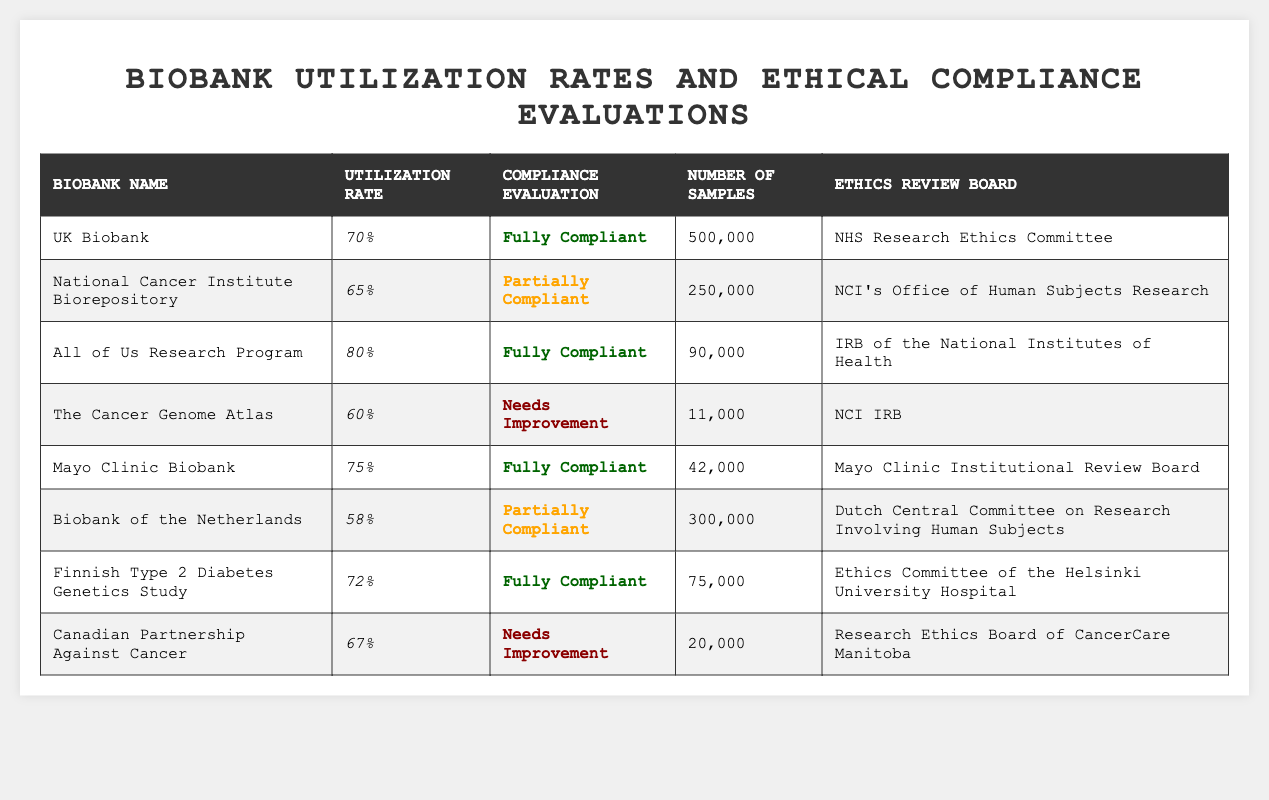What is the utilization rate of the UK Biobank? The table lists the UK Biobank's utilization rate, which is specified directly as 70%.
Answer: 70% How many samples are in the Finnish Type 2 Diabetes Genetics Study? Referring to the table, the number of samples for the Finnish Type 2 Diabetes Genetics Study is stated as 75,000.
Answer: 75,000 Which biobank has the highest utilization rate? Upon comparing the utilization rates listed in the table, the All of Us Research Program has the highest rate at 80%.
Answer: All of Us Research Program What is the compliance evaluation for the Canadian Partnership Against Cancer? The table indicates that the compliance evaluation for the Canadian Partnership Against Cancer is "Needs Improvement."
Answer: Needs Improvement What is the average utilization rate of biobanks with full compliance evaluations? The utilization rates of fully compliant biobanks are 70% (UK Biobank), 80% (All of Us Research), 75% (Mayo Clinic Biobank), and 72% (Finnish Type 2 Diabetes). Their sum is 70 + 80 + 75 + 72 = 297. Dividing by the number of fully compliant biobanks (4), the average utilization rate is 297/4 = 74.25%.
Answer: 74.25% Are there any biobanks that are partially compliant with a utilization rate above 60%? The National Cancer Institute Biorepository (65%) and Biobank of the Netherlands (58%) are the only partially compliant biobanks, and none are above 60%.
Answer: No What is the compliance evaluation of the biobank with the least number of samples? The Cancer Genome Atlas has the least number of samples, listed as 11,000, and its compliance evaluation is "Needs Improvement."
Answer: Needs Improvement What is the difference in utilization rates between the All of Us Research Program and the Biobank of the Netherlands? The utilization rate for the All of Us Research Program is 80%, while the Biobank of the Netherlands is 58%. The difference is 80 - 58 = 22%.
Answer: 22% Which two biobanks have a compliance evaluation of "Partially Compliant"? The table lists the National Cancer Institute Biorepository and the Biobank of the Netherlands as the biobanks with "Partially Compliant" evaluations.
Answer: National Cancer Institute Biorepository and Biobank of the Netherlands What percentage of total samples are from biobanks that have an ethical compliance evaluation of "Needs Improvement"? The total number of samples from biobanks needing improvement is 11,000 (The Cancer Genome Atlas) + 20,000 (Canadian Partnership Against Cancer) = 31,000. The overall total of samples is 500,000 + 250,000 + 90,000 + 11,000 + 42,000 + 300,000 + 75,000 + 20,000 = 1,288,000. The percentage is (31,000 / 1,288,000) * 100 = 2.41%.
Answer: 2.41% 